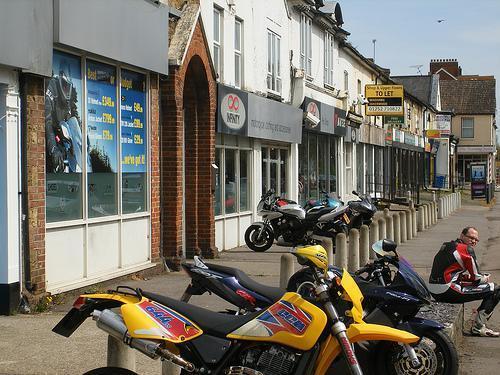How many bikes are shown?
Give a very brief answer. 5. How many people can be seen?
Give a very brief answer. 1. How many bycicles are setting front of the house?
Give a very brief answer. 0. 